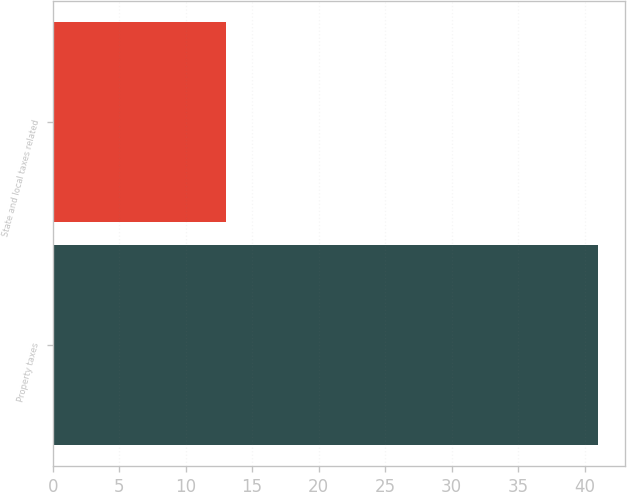Convert chart. <chart><loc_0><loc_0><loc_500><loc_500><bar_chart><fcel>Property taxes<fcel>State and local taxes related<nl><fcel>41<fcel>13<nl></chart> 